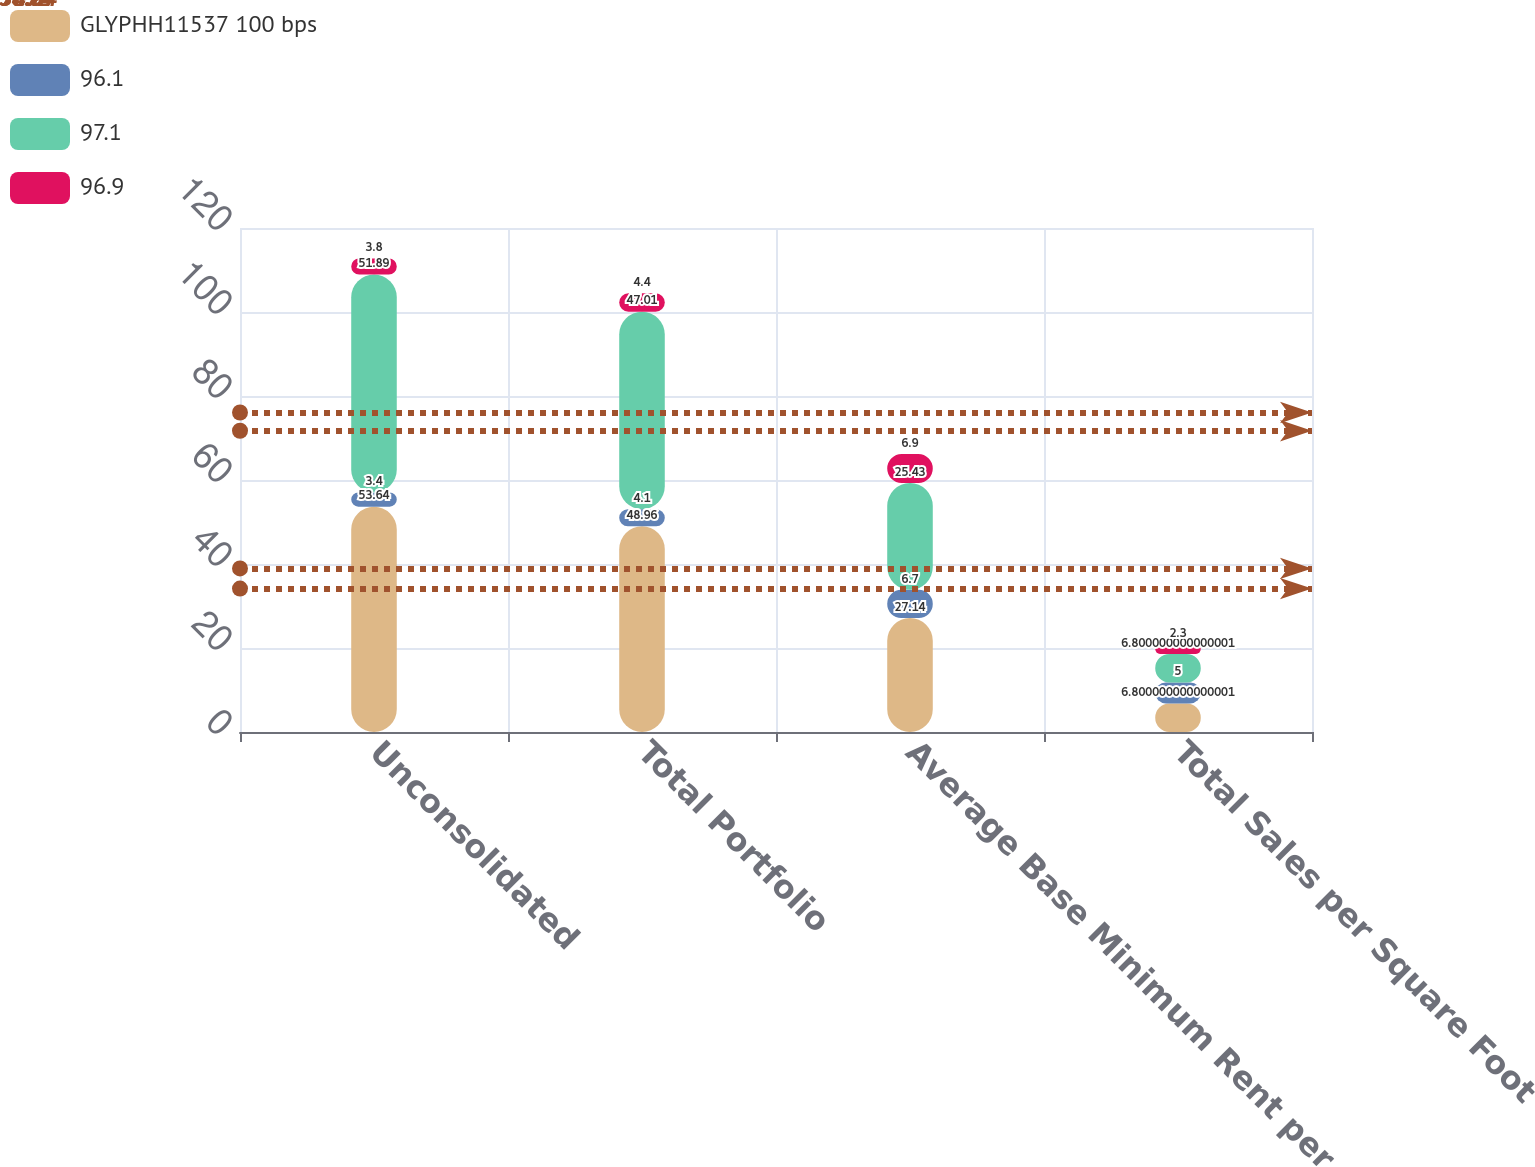Convert chart. <chart><loc_0><loc_0><loc_500><loc_500><stacked_bar_chart><ecel><fcel>Unconsolidated<fcel>Total Portfolio<fcel>Average Base Minimum Rent per<fcel>Total Sales per Square Foot<nl><fcel>GLYPHH11537 100 bps<fcel>53.64<fcel>48.96<fcel>27.14<fcel>6.8<nl><fcel>96.1<fcel>3.4<fcel>4.1<fcel>6.7<fcel>5<nl><fcel>97.1<fcel>51.89<fcel>47.01<fcel>25.43<fcel>6.8<nl><fcel>96.9<fcel>3.8<fcel>4.4<fcel>6.9<fcel>2.3<nl></chart> 